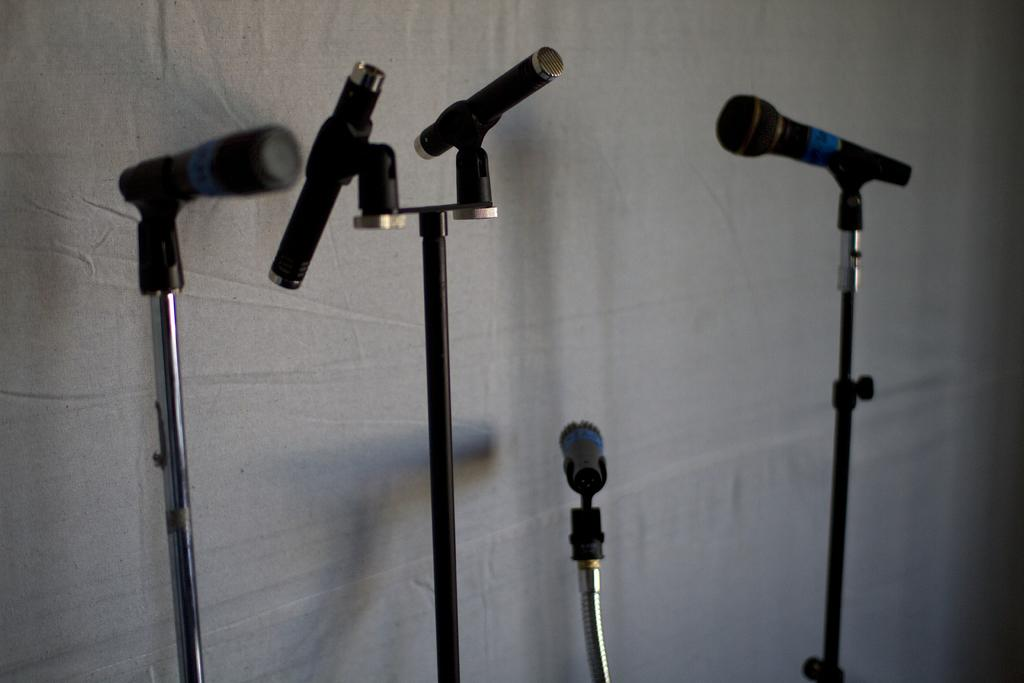What objects are present in the image that are used for amplifying sound? There are microphones in the image. What are the microphones placed on in the image? There are stands for the microphones in the image. What can be seen in the background of the image? There is a wall in the image. What type of animal is sitting on the committee in the image? There is no animal or committee present in the image. What thing is being amplified by the microphones in the image? The image does not show what is being amplified by the microphones; it only shows the microphones and their stands. 